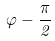<formula> <loc_0><loc_0><loc_500><loc_500>\varphi - { \frac { \pi } { 2 } }</formula> 